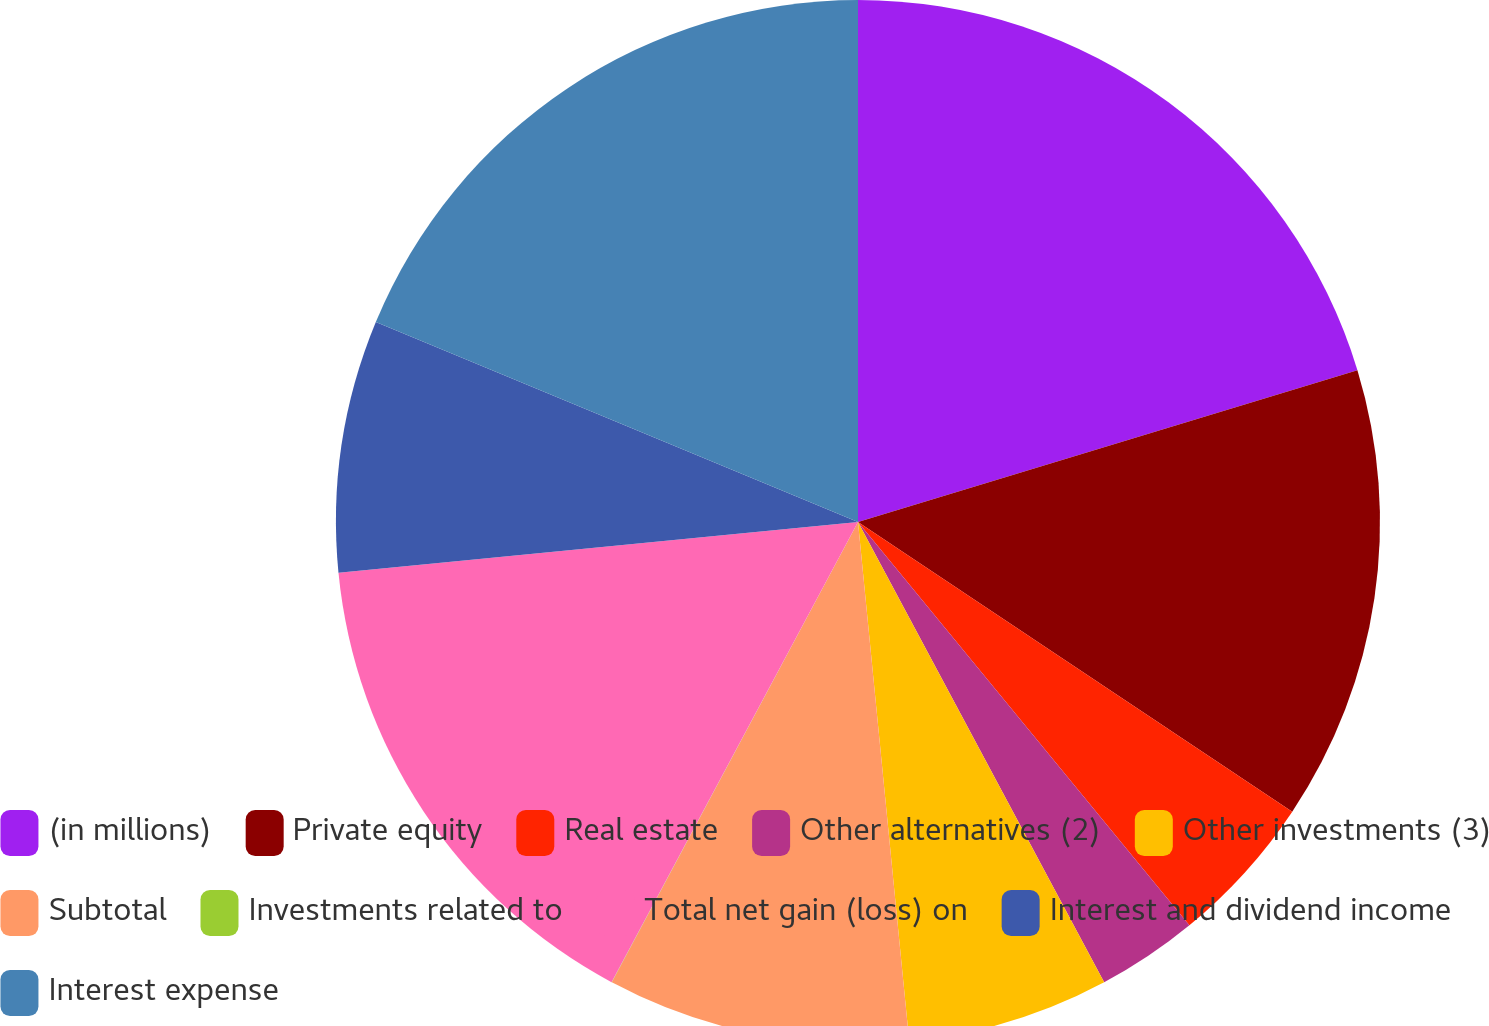<chart> <loc_0><loc_0><loc_500><loc_500><pie_chart><fcel>(in millions)<fcel>Private equity<fcel>Real estate<fcel>Other alternatives (2)<fcel>Other investments (3)<fcel>Subtotal<fcel>Investments related to<fcel>Total net gain (loss) on<fcel>Interest and dividend income<fcel>Interest expense<nl><fcel>20.3%<fcel>14.06%<fcel>4.69%<fcel>3.13%<fcel>6.25%<fcel>9.38%<fcel>0.01%<fcel>15.62%<fcel>7.81%<fcel>18.74%<nl></chart> 